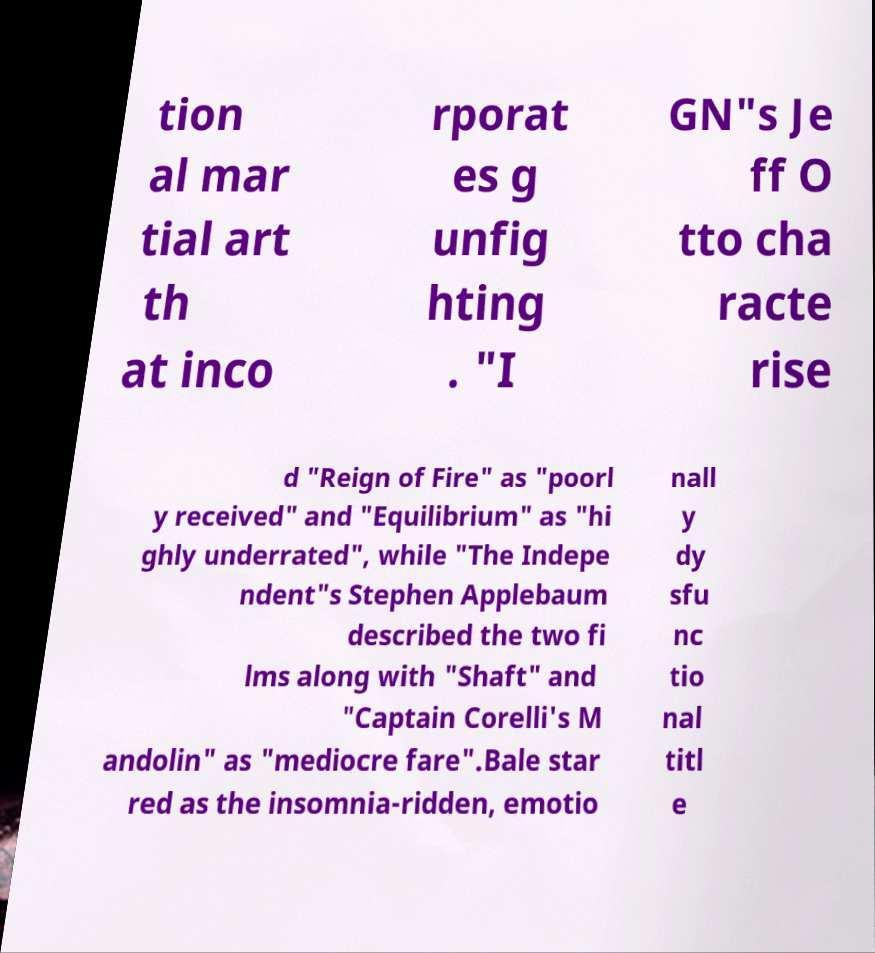Please read and relay the text visible in this image. What does it say? tion al mar tial art th at inco rporat es g unfig hting . "I GN"s Je ff O tto cha racte rise d "Reign of Fire" as "poorl y received" and "Equilibrium" as "hi ghly underrated", while "The Indepe ndent"s Stephen Applebaum described the two fi lms along with "Shaft" and "Captain Corelli's M andolin" as "mediocre fare".Bale star red as the insomnia-ridden, emotio nall y dy sfu nc tio nal titl e 